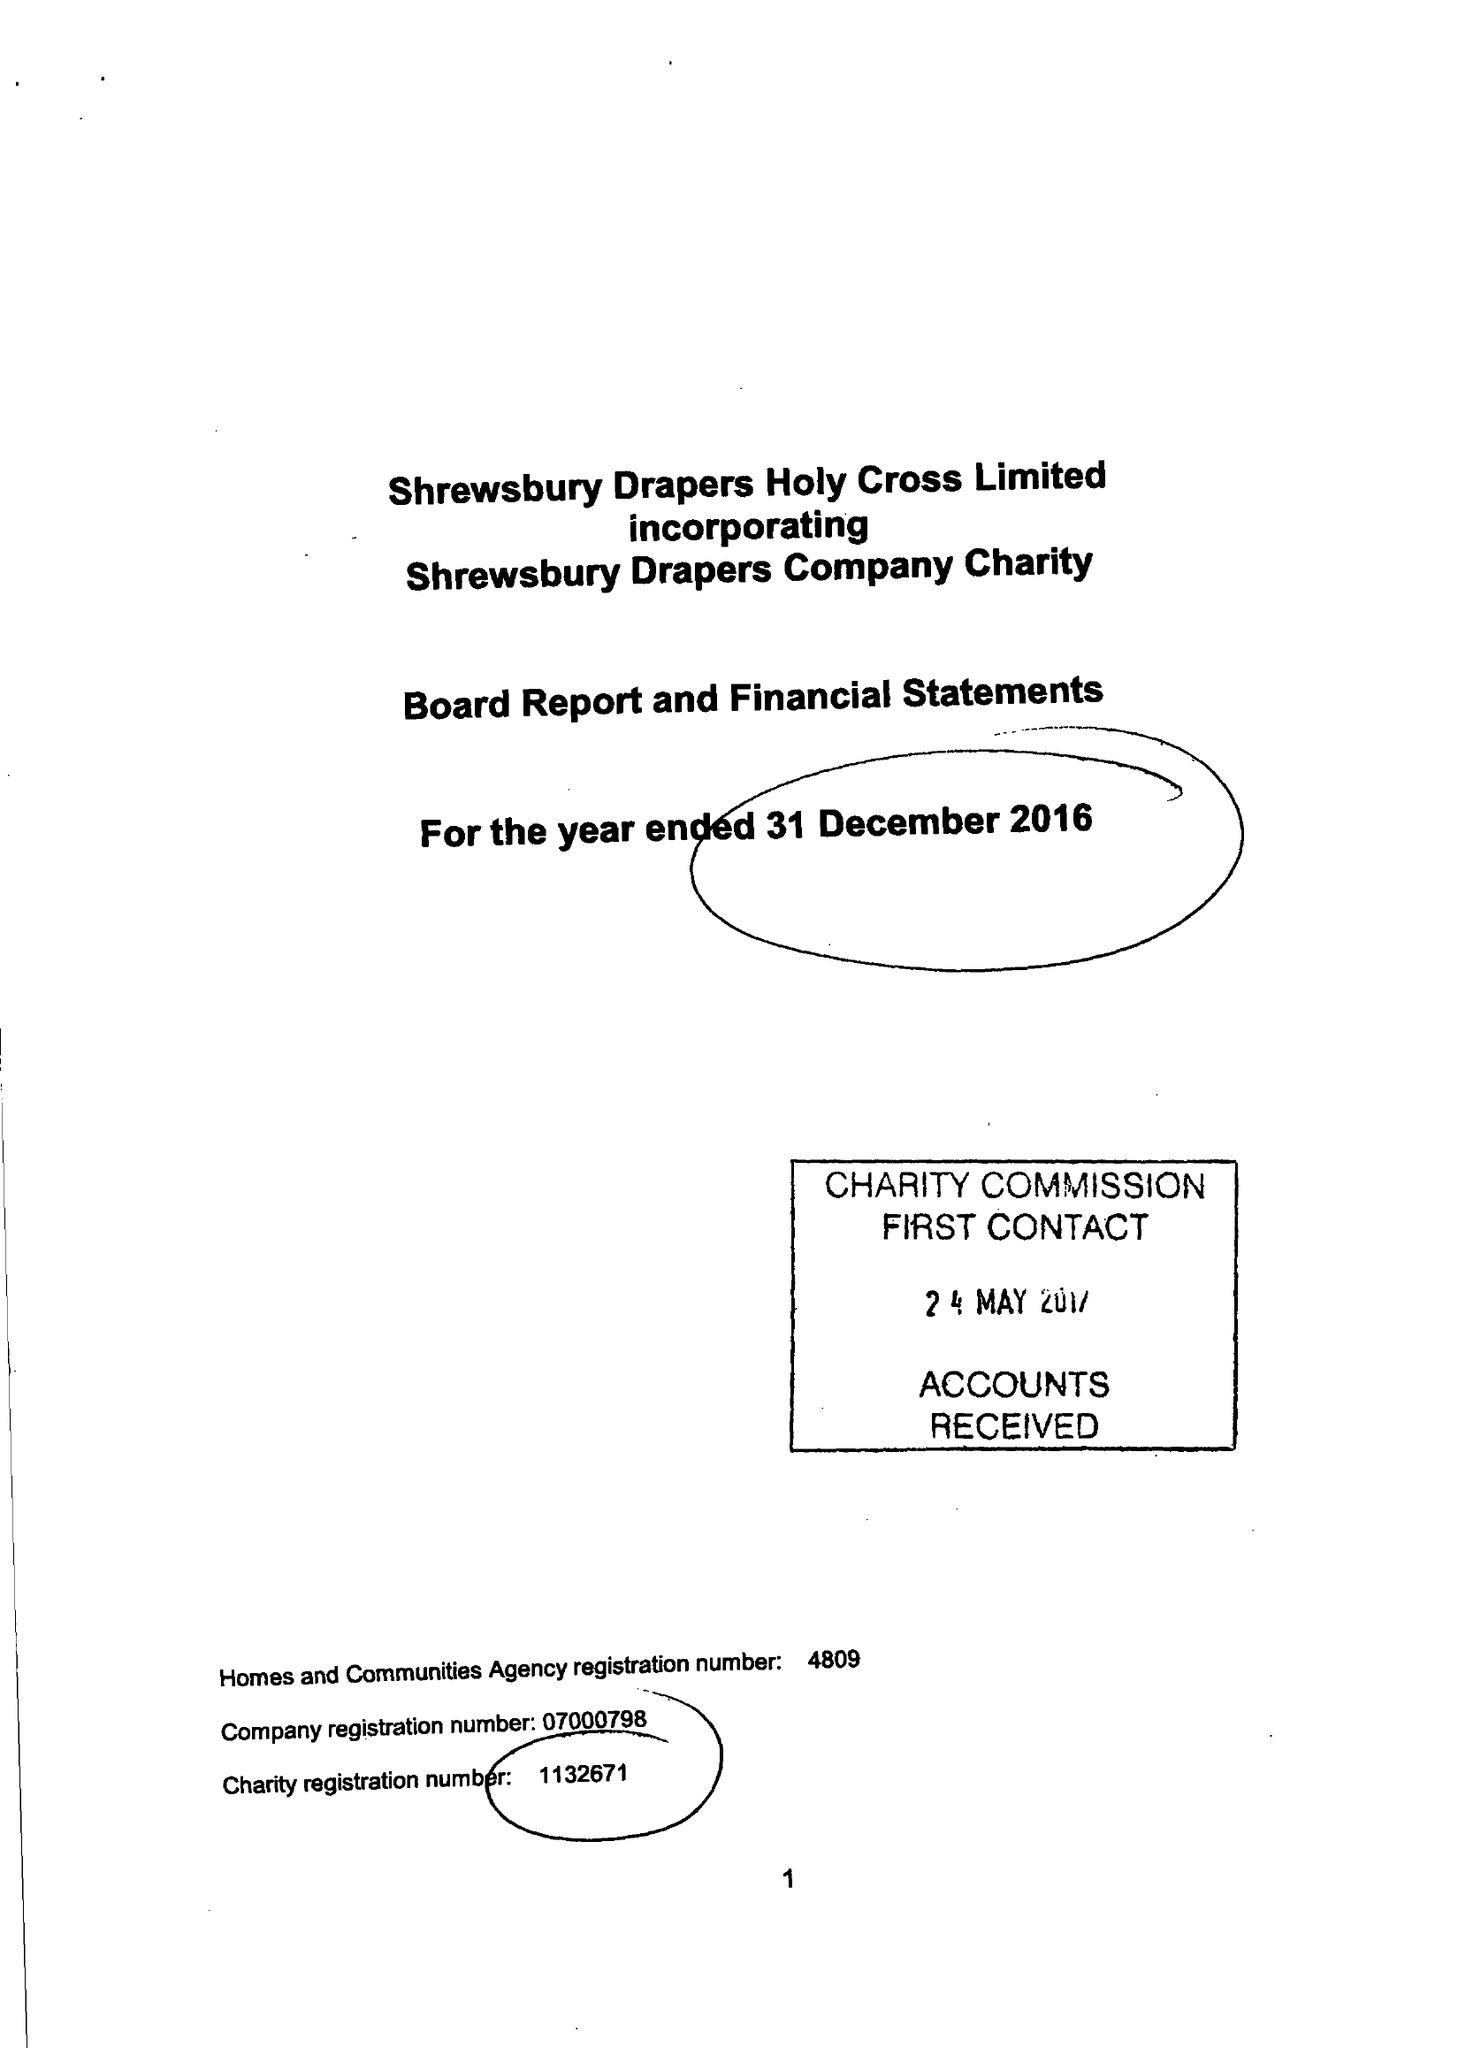What is the value for the charity_name?
Answer the question using a single word or phrase. Shrewsbury Drapers Holy Cross Ltd. 